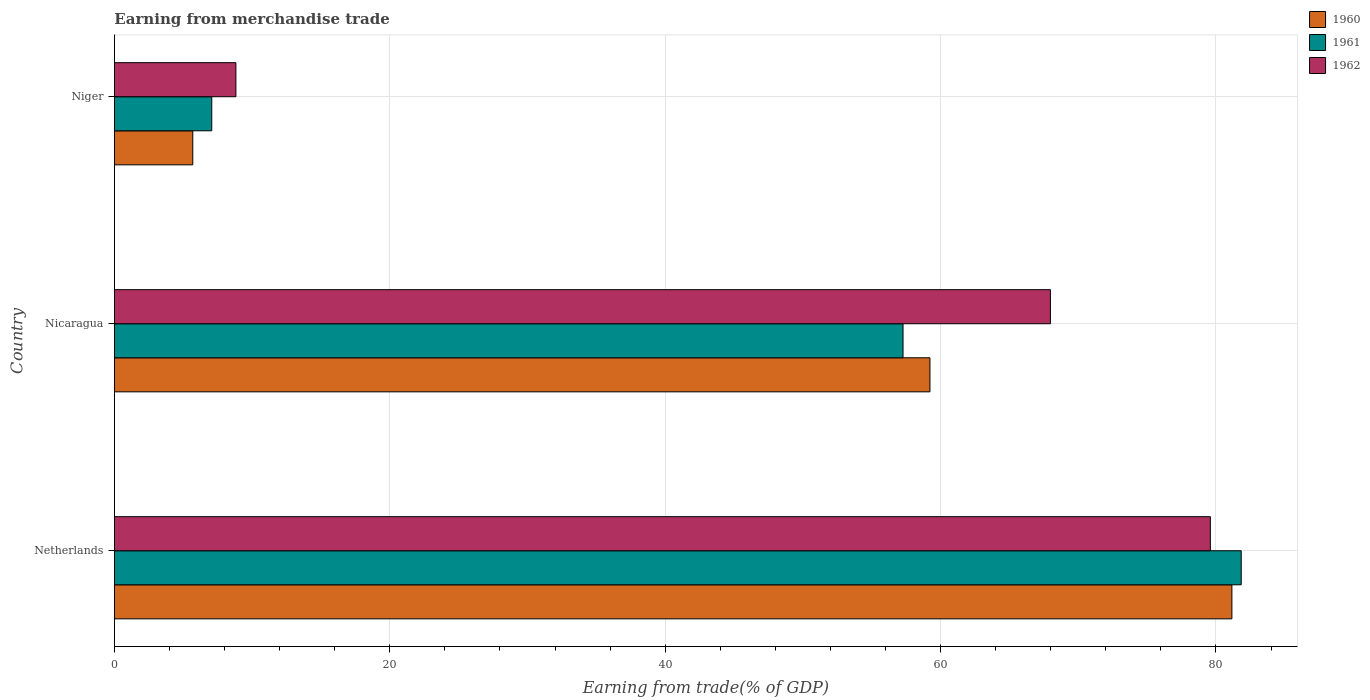How many different coloured bars are there?
Your response must be concise. 3. How many groups of bars are there?
Keep it short and to the point. 3. What is the label of the 1st group of bars from the top?
Provide a short and direct response. Niger. What is the earnings from trade in 1961 in Netherlands?
Your answer should be very brief. 81.83. Across all countries, what is the maximum earnings from trade in 1960?
Give a very brief answer. 81.16. Across all countries, what is the minimum earnings from trade in 1962?
Keep it short and to the point. 8.82. In which country was the earnings from trade in 1960 maximum?
Make the answer very short. Netherlands. In which country was the earnings from trade in 1961 minimum?
Offer a very short reply. Niger. What is the total earnings from trade in 1960 in the graph?
Make the answer very short. 146.08. What is the difference between the earnings from trade in 1960 in Netherlands and that in Nicaragua?
Provide a short and direct response. 21.93. What is the difference between the earnings from trade in 1962 in Nicaragua and the earnings from trade in 1960 in Niger?
Your response must be concise. 62.29. What is the average earnings from trade in 1962 per country?
Provide a succinct answer. 52.13. What is the difference between the earnings from trade in 1962 and earnings from trade in 1961 in Niger?
Make the answer very short. 1.75. What is the ratio of the earnings from trade in 1960 in Netherlands to that in Nicaragua?
Ensure brevity in your answer.  1.37. What is the difference between the highest and the second highest earnings from trade in 1962?
Provide a succinct answer. 11.62. What is the difference between the highest and the lowest earnings from trade in 1960?
Your answer should be very brief. 75.47. Is the sum of the earnings from trade in 1961 in Nicaragua and Niger greater than the maximum earnings from trade in 1962 across all countries?
Ensure brevity in your answer.  No. What does the 1st bar from the bottom in Nicaragua represents?
Your response must be concise. 1960. How many bars are there?
Provide a succinct answer. 9. How many countries are there in the graph?
Your response must be concise. 3. What is the difference between two consecutive major ticks on the X-axis?
Your response must be concise. 20. Are the values on the major ticks of X-axis written in scientific E-notation?
Make the answer very short. No. How many legend labels are there?
Keep it short and to the point. 3. How are the legend labels stacked?
Give a very brief answer. Vertical. What is the title of the graph?
Your response must be concise. Earning from merchandise trade. What is the label or title of the X-axis?
Keep it short and to the point. Earning from trade(% of GDP). What is the label or title of the Y-axis?
Provide a short and direct response. Country. What is the Earning from trade(% of GDP) of 1960 in Netherlands?
Provide a short and direct response. 81.16. What is the Earning from trade(% of GDP) of 1961 in Netherlands?
Offer a very short reply. 81.83. What is the Earning from trade(% of GDP) in 1962 in Netherlands?
Give a very brief answer. 79.59. What is the Earning from trade(% of GDP) in 1960 in Nicaragua?
Offer a very short reply. 59.23. What is the Earning from trade(% of GDP) of 1961 in Nicaragua?
Ensure brevity in your answer.  57.27. What is the Earning from trade(% of GDP) in 1962 in Nicaragua?
Your response must be concise. 67.98. What is the Earning from trade(% of GDP) of 1960 in Niger?
Your answer should be compact. 5.69. What is the Earning from trade(% of GDP) in 1961 in Niger?
Ensure brevity in your answer.  7.07. What is the Earning from trade(% of GDP) of 1962 in Niger?
Give a very brief answer. 8.82. Across all countries, what is the maximum Earning from trade(% of GDP) in 1960?
Offer a terse response. 81.16. Across all countries, what is the maximum Earning from trade(% of GDP) in 1961?
Provide a succinct answer. 81.83. Across all countries, what is the maximum Earning from trade(% of GDP) of 1962?
Your answer should be compact. 79.59. Across all countries, what is the minimum Earning from trade(% of GDP) in 1960?
Your answer should be very brief. 5.69. Across all countries, what is the minimum Earning from trade(% of GDP) in 1961?
Offer a terse response. 7.07. Across all countries, what is the minimum Earning from trade(% of GDP) of 1962?
Your answer should be very brief. 8.82. What is the total Earning from trade(% of GDP) of 1960 in the graph?
Your response must be concise. 146.08. What is the total Earning from trade(% of GDP) of 1961 in the graph?
Provide a short and direct response. 146.18. What is the total Earning from trade(% of GDP) in 1962 in the graph?
Your answer should be compact. 156.39. What is the difference between the Earning from trade(% of GDP) in 1960 in Netherlands and that in Nicaragua?
Your answer should be compact. 21.93. What is the difference between the Earning from trade(% of GDP) in 1961 in Netherlands and that in Nicaragua?
Give a very brief answer. 24.56. What is the difference between the Earning from trade(% of GDP) in 1962 in Netherlands and that in Nicaragua?
Offer a terse response. 11.62. What is the difference between the Earning from trade(% of GDP) in 1960 in Netherlands and that in Niger?
Ensure brevity in your answer.  75.47. What is the difference between the Earning from trade(% of GDP) in 1961 in Netherlands and that in Niger?
Provide a short and direct response. 74.77. What is the difference between the Earning from trade(% of GDP) in 1962 in Netherlands and that in Niger?
Make the answer very short. 70.77. What is the difference between the Earning from trade(% of GDP) in 1960 in Nicaragua and that in Niger?
Your response must be concise. 53.54. What is the difference between the Earning from trade(% of GDP) in 1961 in Nicaragua and that in Niger?
Provide a succinct answer. 50.2. What is the difference between the Earning from trade(% of GDP) in 1962 in Nicaragua and that in Niger?
Offer a very short reply. 59.16. What is the difference between the Earning from trade(% of GDP) in 1960 in Netherlands and the Earning from trade(% of GDP) in 1961 in Nicaragua?
Offer a terse response. 23.88. What is the difference between the Earning from trade(% of GDP) in 1960 in Netherlands and the Earning from trade(% of GDP) in 1962 in Nicaragua?
Ensure brevity in your answer.  13.18. What is the difference between the Earning from trade(% of GDP) of 1961 in Netherlands and the Earning from trade(% of GDP) of 1962 in Nicaragua?
Offer a terse response. 13.86. What is the difference between the Earning from trade(% of GDP) in 1960 in Netherlands and the Earning from trade(% of GDP) in 1961 in Niger?
Offer a terse response. 74.09. What is the difference between the Earning from trade(% of GDP) in 1960 in Netherlands and the Earning from trade(% of GDP) in 1962 in Niger?
Keep it short and to the point. 72.34. What is the difference between the Earning from trade(% of GDP) of 1961 in Netherlands and the Earning from trade(% of GDP) of 1962 in Niger?
Your answer should be very brief. 73.01. What is the difference between the Earning from trade(% of GDP) of 1960 in Nicaragua and the Earning from trade(% of GDP) of 1961 in Niger?
Your answer should be compact. 52.16. What is the difference between the Earning from trade(% of GDP) of 1960 in Nicaragua and the Earning from trade(% of GDP) of 1962 in Niger?
Your answer should be very brief. 50.41. What is the difference between the Earning from trade(% of GDP) in 1961 in Nicaragua and the Earning from trade(% of GDP) in 1962 in Niger?
Your answer should be compact. 48.45. What is the average Earning from trade(% of GDP) of 1960 per country?
Keep it short and to the point. 48.69. What is the average Earning from trade(% of GDP) in 1961 per country?
Provide a short and direct response. 48.73. What is the average Earning from trade(% of GDP) of 1962 per country?
Offer a very short reply. 52.13. What is the difference between the Earning from trade(% of GDP) of 1960 and Earning from trade(% of GDP) of 1961 in Netherlands?
Provide a succinct answer. -0.68. What is the difference between the Earning from trade(% of GDP) of 1960 and Earning from trade(% of GDP) of 1962 in Netherlands?
Keep it short and to the point. 1.56. What is the difference between the Earning from trade(% of GDP) of 1961 and Earning from trade(% of GDP) of 1962 in Netherlands?
Your answer should be compact. 2.24. What is the difference between the Earning from trade(% of GDP) of 1960 and Earning from trade(% of GDP) of 1961 in Nicaragua?
Keep it short and to the point. 1.95. What is the difference between the Earning from trade(% of GDP) in 1960 and Earning from trade(% of GDP) in 1962 in Nicaragua?
Ensure brevity in your answer.  -8.75. What is the difference between the Earning from trade(% of GDP) of 1961 and Earning from trade(% of GDP) of 1962 in Nicaragua?
Ensure brevity in your answer.  -10.7. What is the difference between the Earning from trade(% of GDP) of 1960 and Earning from trade(% of GDP) of 1961 in Niger?
Offer a terse response. -1.38. What is the difference between the Earning from trade(% of GDP) in 1960 and Earning from trade(% of GDP) in 1962 in Niger?
Give a very brief answer. -3.13. What is the difference between the Earning from trade(% of GDP) of 1961 and Earning from trade(% of GDP) of 1962 in Niger?
Your answer should be very brief. -1.75. What is the ratio of the Earning from trade(% of GDP) in 1960 in Netherlands to that in Nicaragua?
Make the answer very short. 1.37. What is the ratio of the Earning from trade(% of GDP) in 1961 in Netherlands to that in Nicaragua?
Offer a very short reply. 1.43. What is the ratio of the Earning from trade(% of GDP) in 1962 in Netherlands to that in Nicaragua?
Provide a succinct answer. 1.17. What is the ratio of the Earning from trade(% of GDP) of 1960 in Netherlands to that in Niger?
Keep it short and to the point. 14.26. What is the ratio of the Earning from trade(% of GDP) of 1961 in Netherlands to that in Niger?
Offer a very short reply. 11.58. What is the ratio of the Earning from trade(% of GDP) in 1962 in Netherlands to that in Niger?
Ensure brevity in your answer.  9.02. What is the ratio of the Earning from trade(% of GDP) in 1960 in Nicaragua to that in Niger?
Your answer should be very brief. 10.41. What is the ratio of the Earning from trade(% of GDP) of 1961 in Nicaragua to that in Niger?
Your response must be concise. 8.1. What is the ratio of the Earning from trade(% of GDP) of 1962 in Nicaragua to that in Niger?
Your response must be concise. 7.71. What is the difference between the highest and the second highest Earning from trade(% of GDP) in 1960?
Your response must be concise. 21.93. What is the difference between the highest and the second highest Earning from trade(% of GDP) of 1961?
Ensure brevity in your answer.  24.56. What is the difference between the highest and the second highest Earning from trade(% of GDP) in 1962?
Make the answer very short. 11.62. What is the difference between the highest and the lowest Earning from trade(% of GDP) of 1960?
Provide a succinct answer. 75.47. What is the difference between the highest and the lowest Earning from trade(% of GDP) in 1961?
Provide a succinct answer. 74.77. What is the difference between the highest and the lowest Earning from trade(% of GDP) in 1962?
Your answer should be compact. 70.77. 